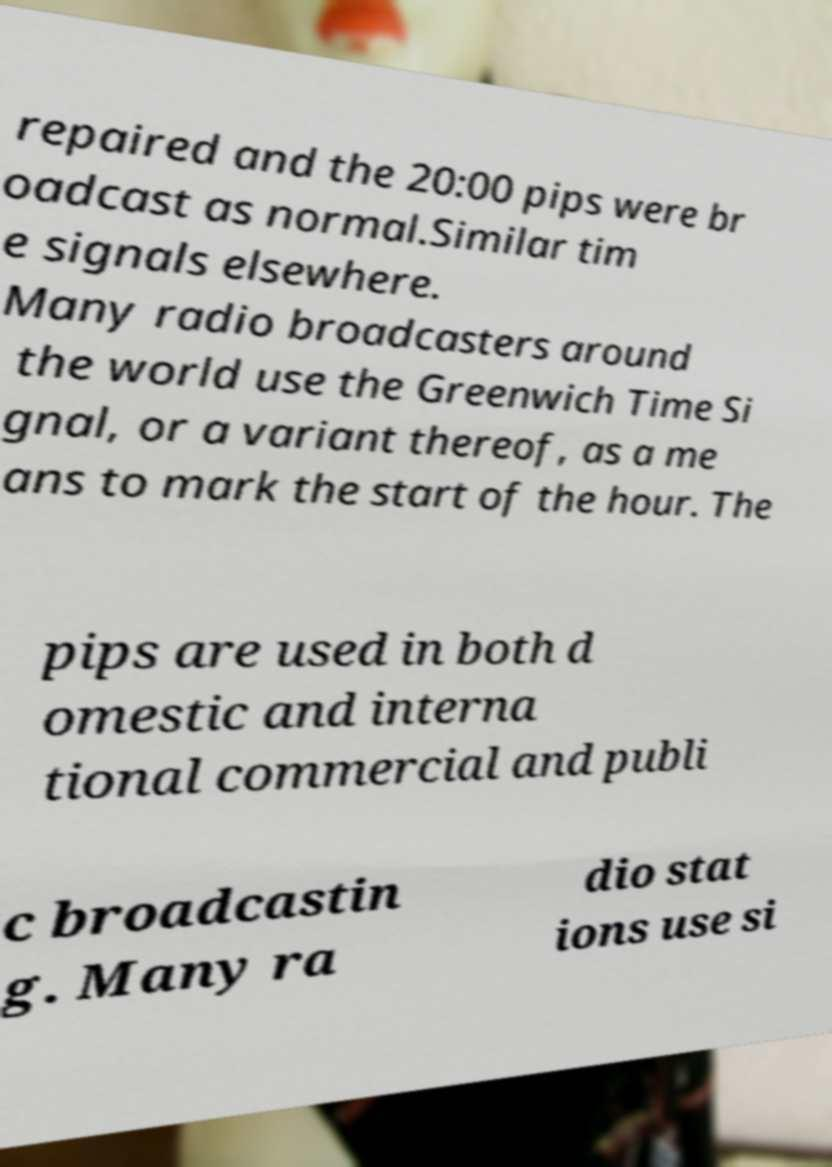Can you read and provide the text displayed in the image?This photo seems to have some interesting text. Can you extract and type it out for me? repaired and the 20:00 pips were br oadcast as normal.Similar tim e signals elsewhere. Many radio broadcasters around the world use the Greenwich Time Si gnal, or a variant thereof, as a me ans to mark the start of the hour. The pips are used in both d omestic and interna tional commercial and publi c broadcastin g. Many ra dio stat ions use si 